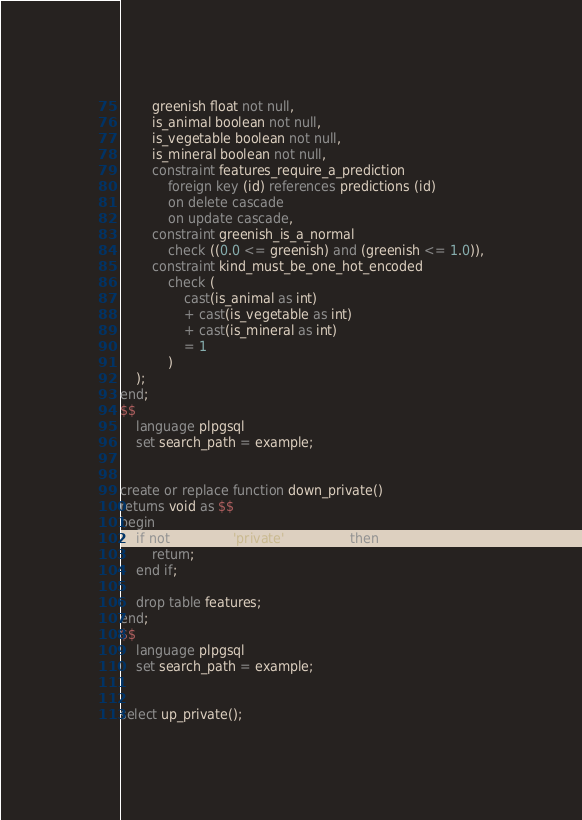Convert code to text. <code><loc_0><loc_0><loc_500><loc_500><_SQL_>        greenish float not null,
        is_animal boolean not null,
        is_vegetable boolean not null,
        is_mineral boolean not null,
        constraint features_require_a_prediction
            foreign key (id) references predictions (id)
            on delete cascade
            on update cascade,
        constraint greenish_is_a_normal
            check ((0.0 <= greenish) and (greenish <= 1.0)),
        constraint kind_must_be_one_hot_encoded
            check (
                cast(is_animal as int)
                + cast(is_vegetable as int)
                + cast(is_mineral as int)
                = 1
            )
    );
end;
$$
    language plpgsql
    set search_path = example;


create or replace function down_private()
returns void as $$
begin
    if not uninstall('private'::varchar) then
        return;
    end if;

    drop table features;
end;
$$
    language plpgsql
    set search_path = example;


select up_private();
</code> 